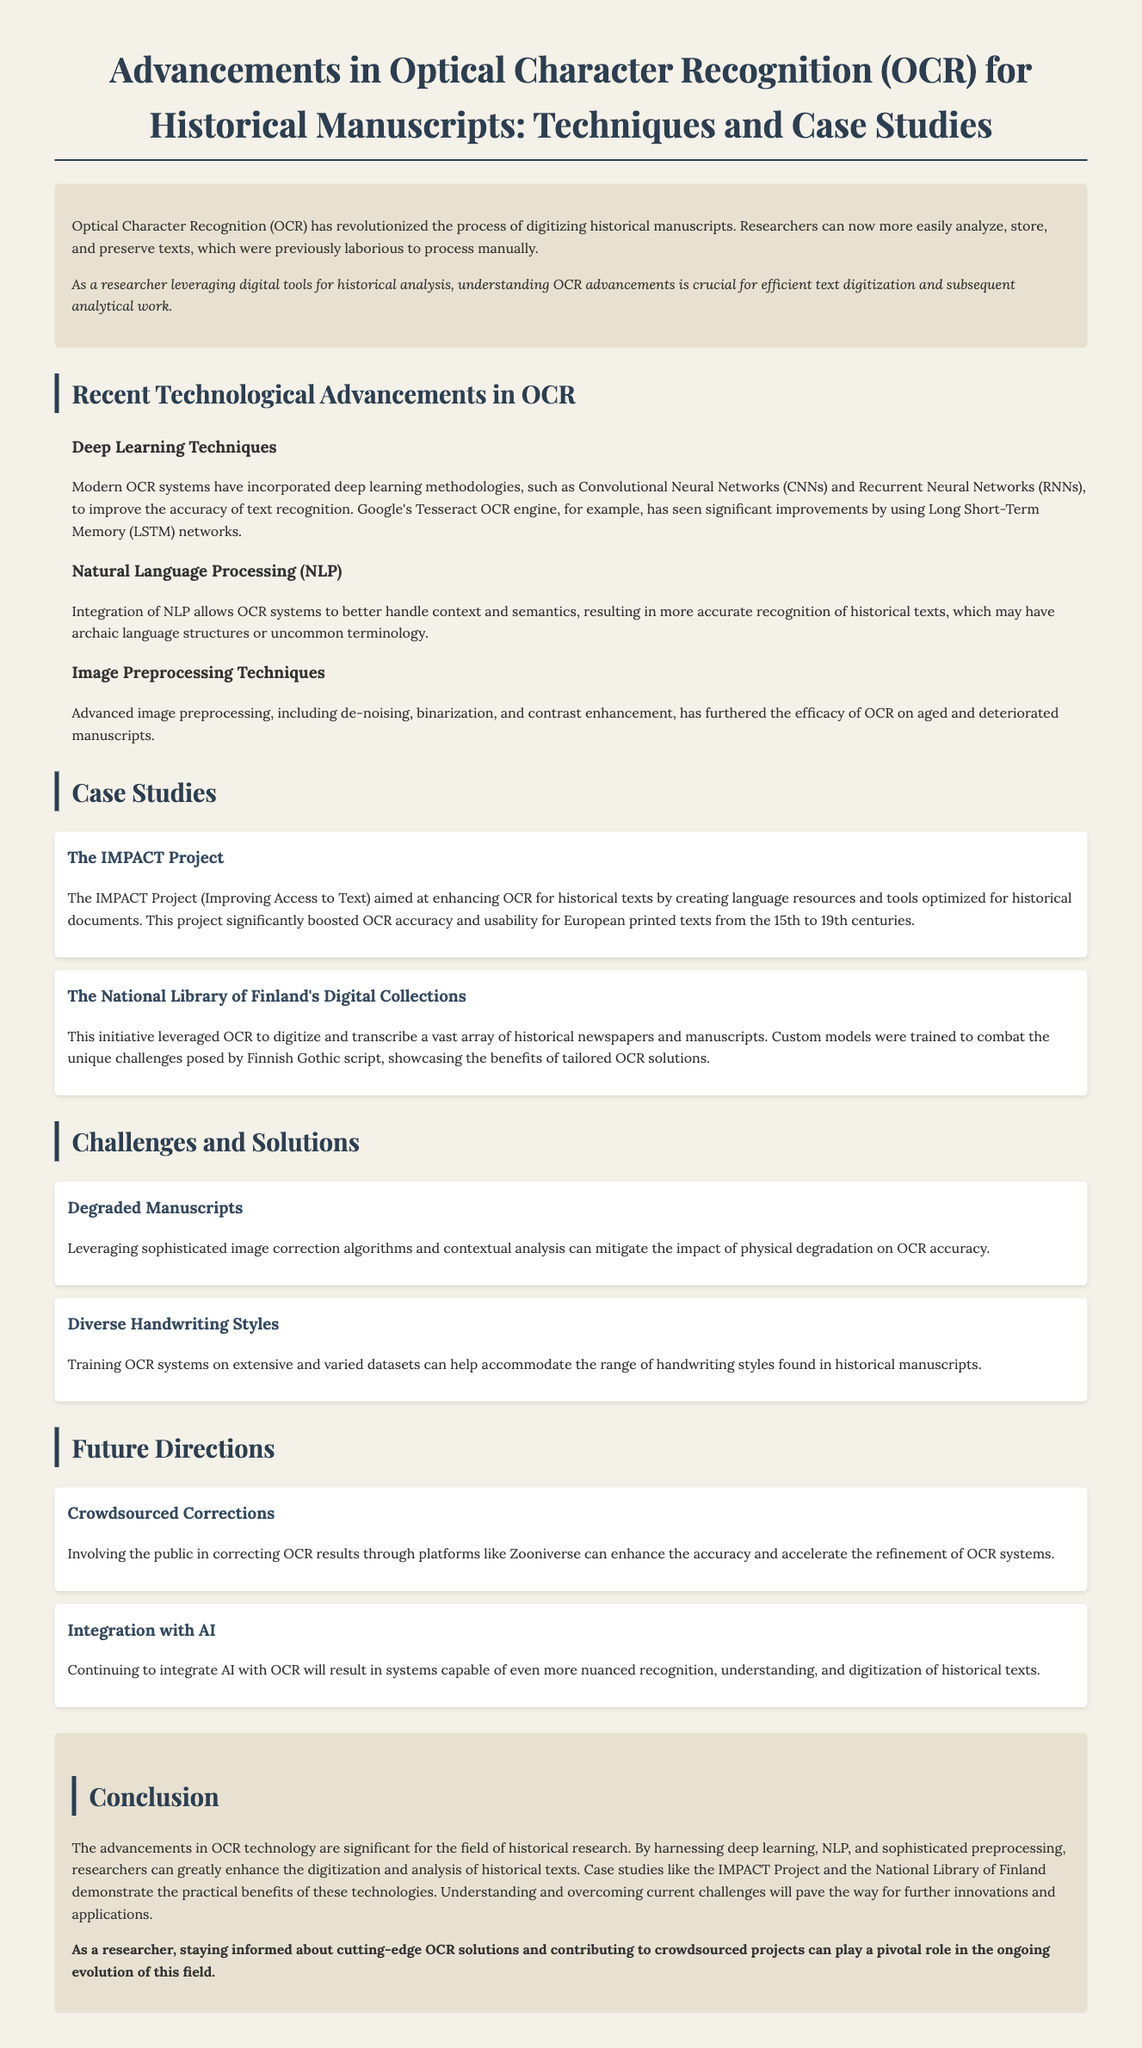What is the title of the document? The title of the document is clearly stated at the top of the paper.
Answer: Advancements in Optical Character Recognition (OCR) for Historical Manuscripts: Techniques and Case Studies What project focused on enhancing OCR for historical texts? The document mentions a specific project aimed at improving OCR technologies for historical documents.
Answer: The IMPACT Project Which type of neural networks improvements were mentioned in OCR advancements? The document refers to specific types of neural networks that are incorporated into modern OCR systems.
Answer: Convolutional Neural Networks (CNNs) and Recurrent Neural Networks (RNNs) What is one challenge in OCR for historical manuscripts? The text discusses specific issues that OCR encounters when dealing with historical manuscripts.
Answer: Degraded Manuscripts Which technological integration improves OCR's handling of context? The document highlights a specific technology that is integrated into OCR systems for better recognition accuracy of historical texts.
Answer: Natural Language Processing (NLP) What has been shown to enhance OCR accuracy in Finnish Gothic script? The text describes custom approaches taken for addressing specific challenges in OCR systems based on unique script requirements.
Answer: Custom models What is a future trend mentioned that involves public participation? The document indicates a trend that encourages public involvement with OCR results.
Answer: Crowdsourced Corrections Which project exemplified practical benefits of advanced OCR technology? The paper provides examples of projects that have successfully implemented OCR advancements.
Answer: The National Library of Finland's Digital Collections What is one method to mitigate the impact of physical degradation on OCR accuracy? The document includes specific techniques used to address the degradation of manuscripts in OCR processing.
Answer: Sophisticated image correction algorithms 